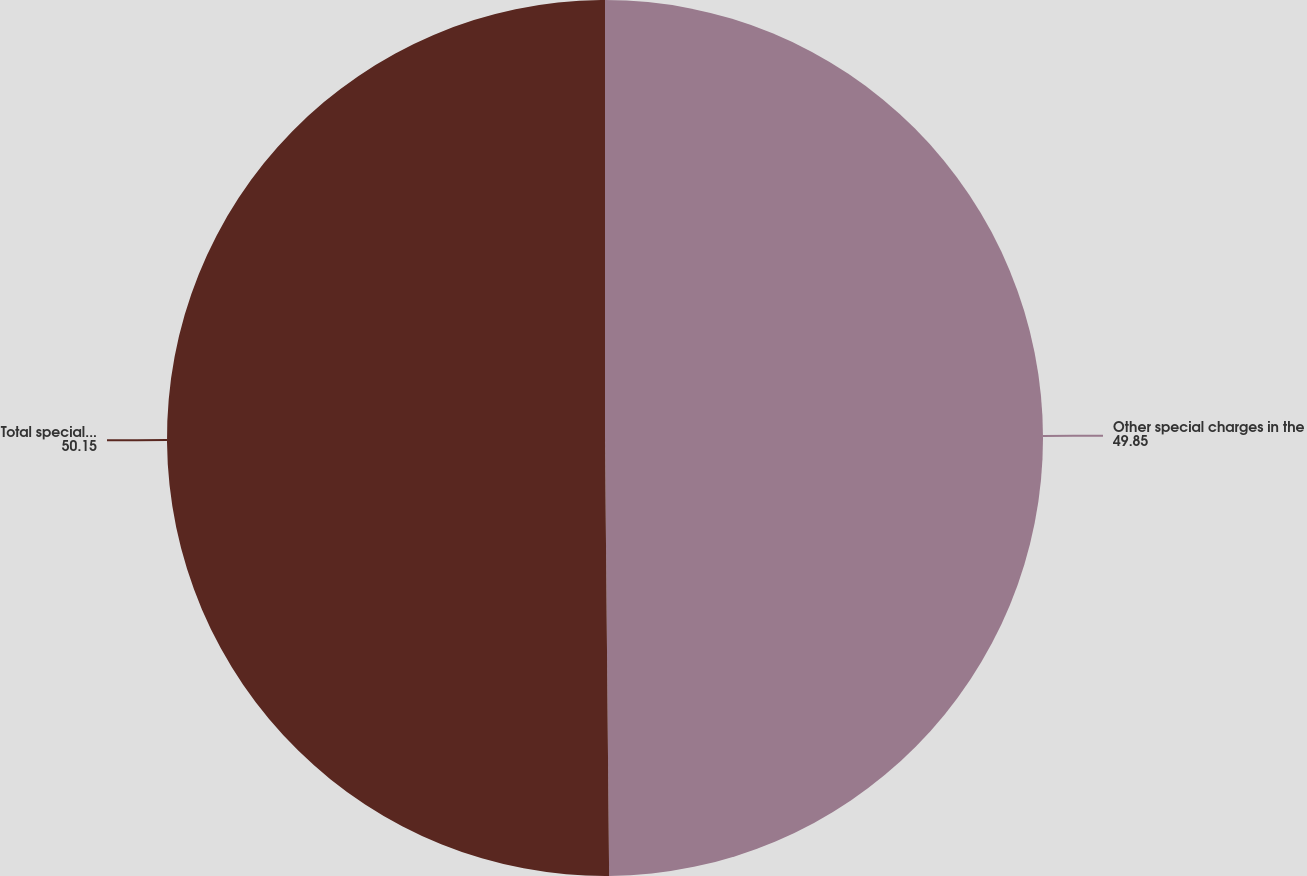<chart> <loc_0><loc_0><loc_500><loc_500><pie_chart><fcel>Other special charges in the<fcel>Total special charges<nl><fcel>49.85%<fcel>50.15%<nl></chart> 